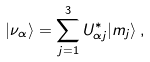<formula> <loc_0><loc_0><loc_500><loc_500>| \nu _ { \alpha } \rangle = \sum _ { j = 1 } ^ { 3 } U _ { \alpha j } ^ { * } | m _ { j } \rangle \, ,</formula> 